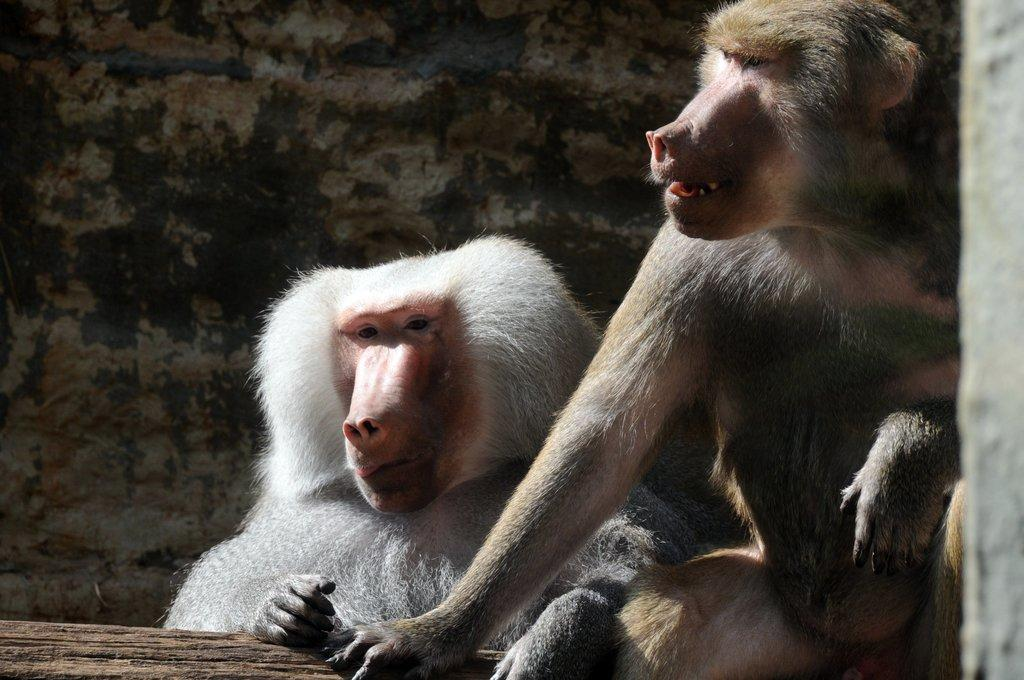How many animals are present in the image? There are two animals in the image. What colors can be seen on the animals? The animals have white, pink, black, and brown colors. What object can be seen in the image besides the animals? There is a wooden log in the image. What is visible in the background of the image? There is a wall in the background of the image. What type of machine can be seen in the image? There is no machine present in the image. 